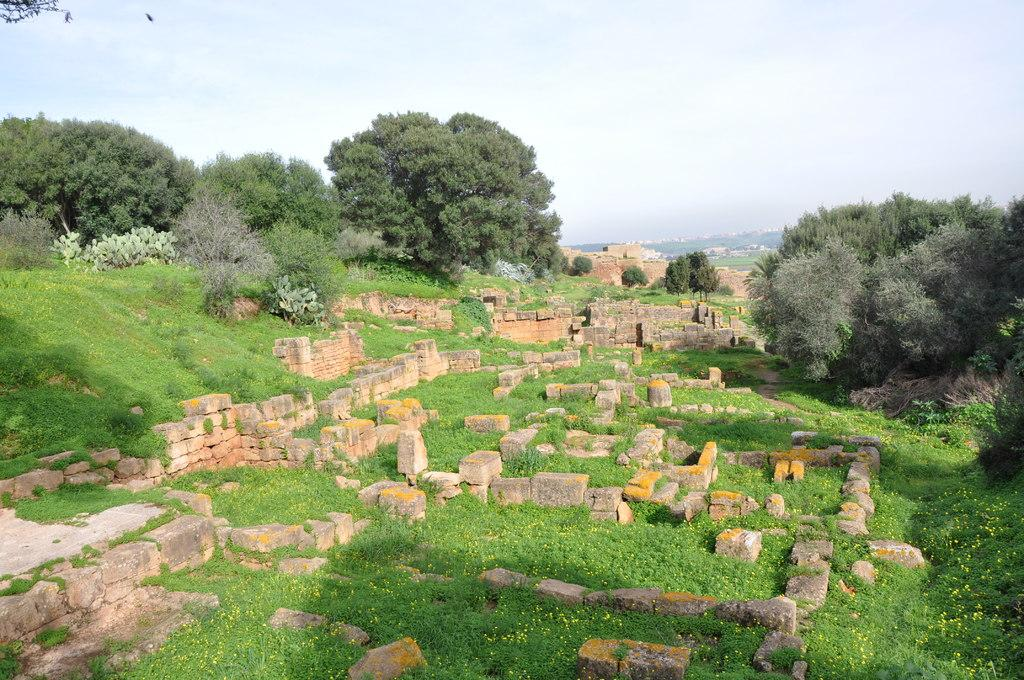What type of structure is visible in the image? There are stone walls in the image. What is on the ground in the image? There is grass on the ground in the image. What other natural elements can be seen in the image? There are trees in the image. What is visible in the background of the image? The sky is visible in the background of the image. Can you describe the sea in the image? There is no sea present in the image; it features stone walls, grass, trees, and the sky. What type of fight is taking place in the image? There is no fight depicted in the image; it shows a natural landscape with stone walls, grass, trees, and the sky. 